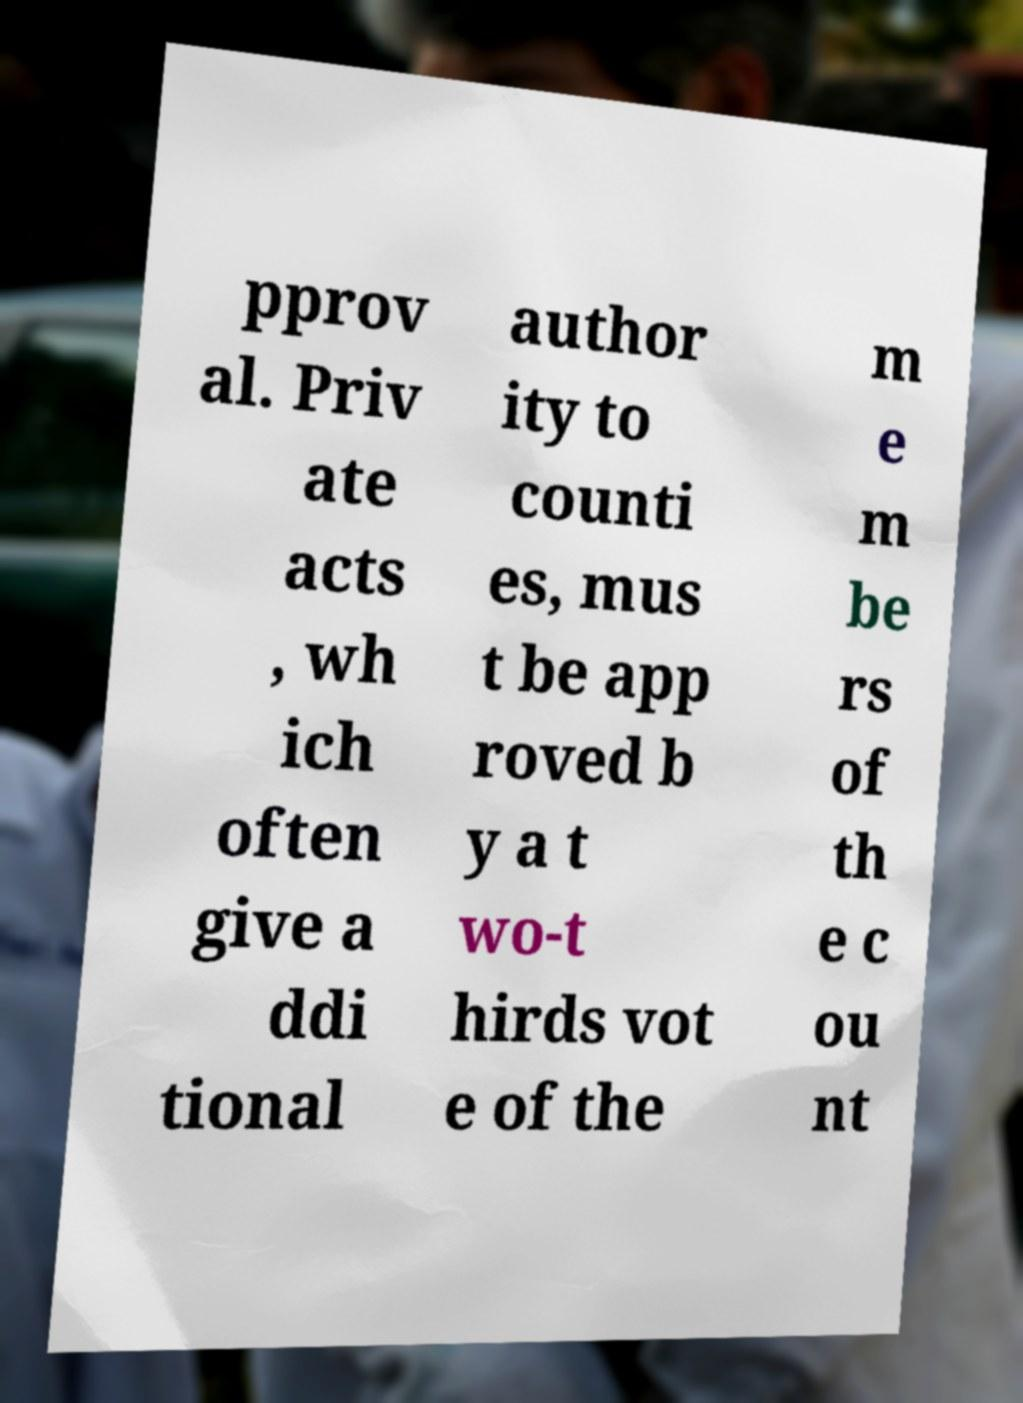Please identify and transcribe the text found in this image. pprov al. Priv ate acts , wh ich often give a ddi tional author ity to counti es, mus t be app roved b y a t wo-t hirds vot e of the m e m be rs of th e c ou nt 